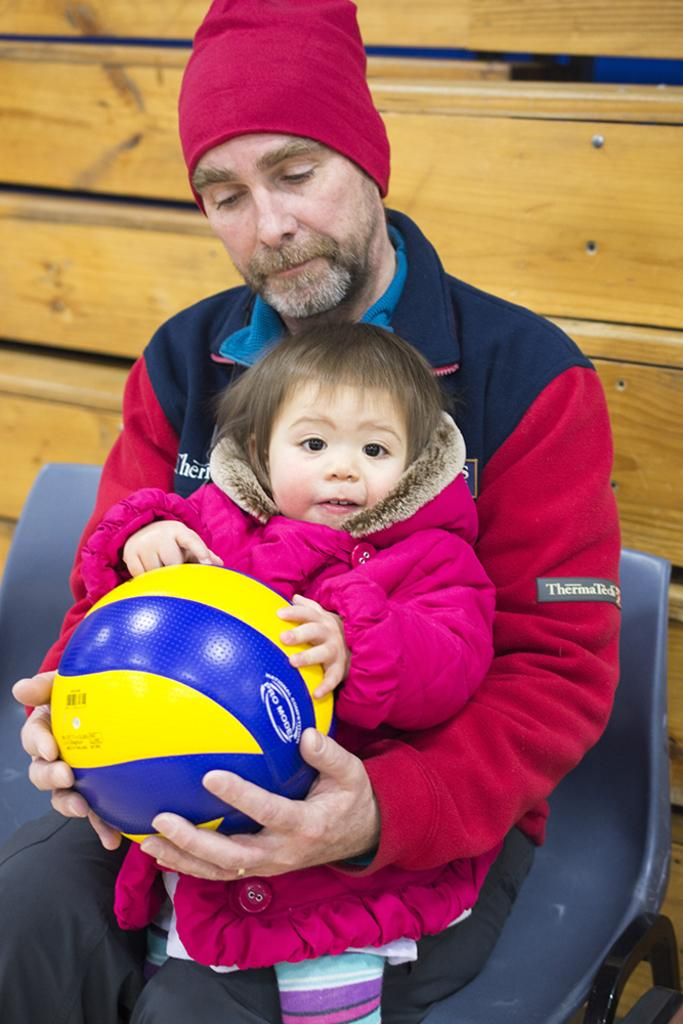Who is present in the image? There is a man and a baby in the image. What are they doing together? The man and baby are holding a ball. Where are they sitting? They are sitting on a chair. What can be seen in the background of the image? There is a wooden wall in the background of the image. What type of knowledge can be gained from the dolls in the image? There are no dolls present in the image, so no knowledge can be gained from them. 